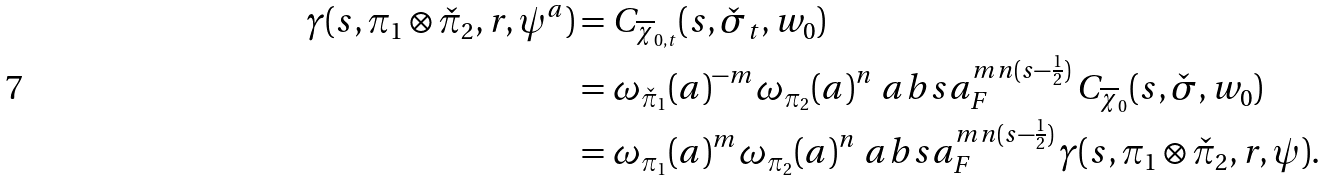<formula> <loc_0><loc_0><loc_500><loc_500>\gamma ( s , \pi _ { 1 } \otimes \check { \pi } _ { 2 } , r , \psi ^ { a } ) & = C _ { \overline { \chi } _ { 0 , t } } ( s , \check { \sigma } _ { t } , w _ { 0 } ) \\ & = \omega _ { \check { \pi } _ { 1 } } ( a ) ^ { - m } \omega _ { { \pi } _ { 2 } } ( a ) ^ { n } \ a b s { a } _ { F } ^ { m n ( s - \frac { 1 } { 2 } ) } \, C _ { \overline { \chi } _ { 0 } } ( s , \check { \sigma } , w _ { 0 } ) \\ & = \omega _ { \pi _ { 1 } } ( a ) ^ { m } \omega _ { \pi _ { 2 } } ( a ) ^ { n } \ a b s { a } _ { F } ^ { m n ( s - \frac { 1 } { 2 } ) } \, \gamma ( s , \pi _ { 1 } \otimes \check { \pi } _ { 2 } , r , \psi ) .</formula> 